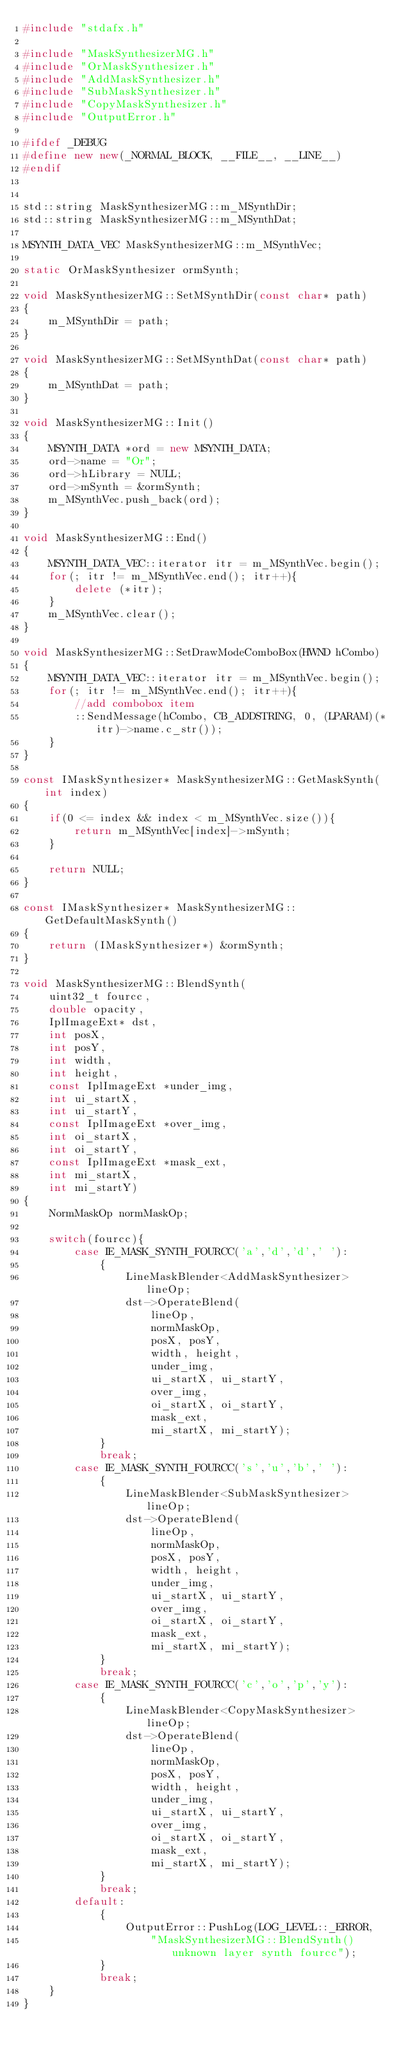<code> <loc_0><loc_0><loc_500><loc_500><_C++_>#include "stdafx.h"

#include "MaskSynthesizerMG.h"
#include "OrMaskSynthesizer.h"
#include "AddMaskSynthesizer.h"
#include "SubMaskSynthesizer.h"
#include "CopyMaskSynthesizer.h"
#include "OutputError.h"

#ifdef _DEBUG
#define new new(_NORMAL_BLOCK, __FILE__, __LINE__)
#endif


std::string MaskSynthesizerMG::m_MSynthDir;
std::string MaskSynthesizerMG::m_MSynthDat;

MSYNTH_DATA_VEC MaskSynthesizerMG::m_MSynthVec;

static OrMaskSynthesizer ormSynth;

void MaskSynthesizerMG::SetMSynthDir(const char* path)
{
	m_MSynthDir = path;
}

void MaskSynthesizerMG::SetMSynthDat(const char* path)
{
	m_MSynthDat = path;
}

void MaskSynthesizerMG::Init()
{
	MSYNTH_DATA *ord = new MSYNTH_DATA;
	ord->name = "Or";
	ord->hLibrary = NULL;
	ord->mSynth = &ormSynth;
	m_MSynthVec.push_back(ord);
}

void MaskSynthesizerMG::End()
{
	MSYNTH_DATA_VEC::iterator itr = m_MSynthVec.begin();
	for(; itr != m_MSynthVec.end(); itr++){
		delete (*itr);
	}
	m_MSynthVec.clear();
}

void MaskSynthesizerMG::SetDrawModeComboBox(HWND hCombo)
{
	MSYNTH_DATA_VEC::iterator itr = m_MSynthVec.begin();
	for(; itr != m_MSynthVec.end(); itr++){
		//add combobox item
		::SendMessage(hCombo, CB_ADDSTRING, 0, (LPARAM)(*itr)->name.c_str());
	}
}

const IMaskSynthesizer* MaskSynthesizerMG::GetMaskSynth(int index)
{
	if(0 <= index && index < m_MSynthVec.size()){
		return m_MSynthVec[index]->mSynth;
	}

	return NULL;
}

const IMaskSynthesizer* MaskSynthesizerMG::GetDefaultMaskSynth()
{
	return (IMaskSynthesizer*) &ormSynth;
}

void MaskSynthesizerMG::BlendSynth(
	uint32_t fourcc,
	double opacity,
	IplImageExt* dst,
	int posX,
	int posY,
	int width,
	int height,
	const IplImageExt *under_img,
	int ui_startX,
	int ui_startY,
	const IplImageExt *over_img,
	int oi_startX,
	int oi_startY,
	const IplImageExt *mask_ext,
	int mi_startX,
	int mi_startY)
{
	NormMaskOp normMaskOp;

	switch(fourcc){
		case IE_MASK_SYNTH_FOURCC('a','d','d',' '):
			{
				LineMaskBlender<AddMaskSynthesizer> lineOp;
				dst->OperateBlend(
					lineOp,
					normMaskOp,
					posX, posY,
					width, height,
					under_img,
					ui_startX, ui_startY,
					over_img,
					oi_startX, oi_startY,
					mask_ext,
					mi_startX, mi_startY);
			}
			break;
		case IE_MASK_SYNTH_FOURCC('s','u','b',' '):
			{
				LineMaskBlender<SubMaskSynthesizer> lineOp;
				dst->OperateBlend(
					lineOp,
					normMaskOp,
					posX, posY,
					width, height,
					under_img,
					ui_startX, ui_startY,
					over_img,
					oi_startX, oi_startY,
					mask_ext,
					mi_startX, mi_startY);
			}
			break;
		case IE_MASK_SYNTH_FOURCC('c','o','p','y'):
			{
				LineMaskBlender<CopyMaskSynthesizer> lineOp;
				dst->OperateBlend(
					lineOp,
					normMaskOp,
					posX, posY,
					width, height,
					under_img,
					ui_startX, ui_startY,
					over_img,
					oi_startX, oi_startY,
					mask_ext,
					mi_startX, mi_startY);
			}
			break;
		default:
			{
				OutputError::PushLog(LOG_LEVEL::_ERROR,
					"MaskSynthesizerMG::BlendSynth() unknown layer synth fourcc");
			}
			break;
	}
}</code> 